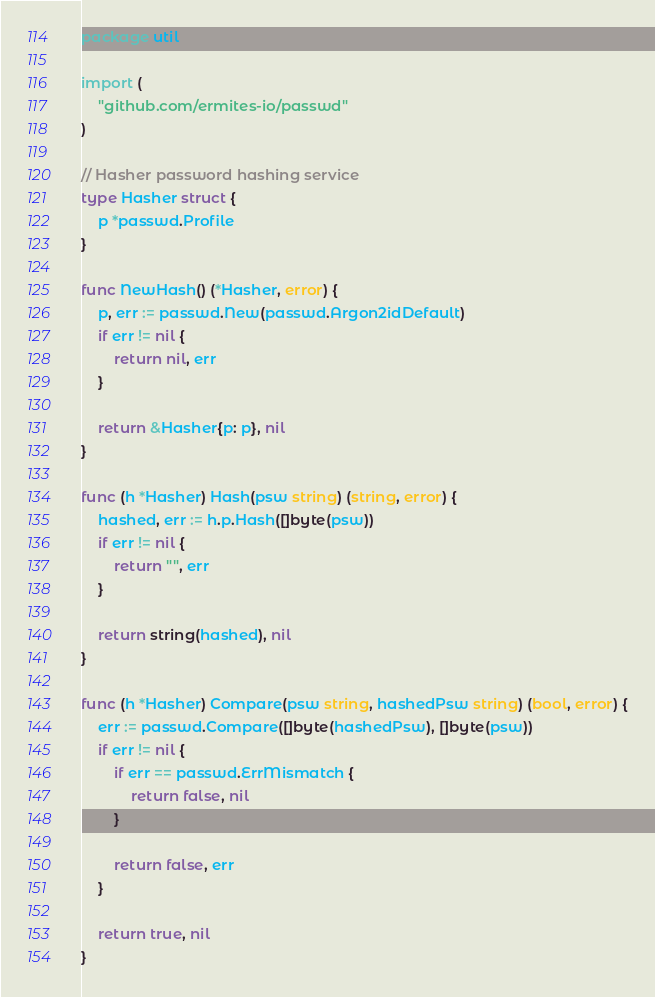Convert code to text. <code><loc_0><loc_0><loc_500><loc_500><_Go_>package util

import (
	"github.com/ermites-io/passwd"
)

// Hasher password hashing service
type Hasher struct {
	p *passwd.Profile
}

func NewHash() (*Hasher, error) {
	p, err := passwd.New(passwd.Argon2idDefault)
	if err != nil {
		return nil, err
	}

	return &Hasher{p: p}, nil
}

func (h *Hasher) Hash(psw string) (string, error) {
	hashed, err := h.p.Hash([]byte(psw))
	if err != nil {
		return "", err
	}

	return string(hashed), nil
}

func (h *Hasher) Compare(psw string, hashedPsw string) (bool, error) {
	err := passwd.Compare([]byte(hashedPsw), []byte(psw))
	if err != nil {
		if err == passwd.ErrMismatch {
			return false, nil
		}

		return false, err
	}

	return true, nil
}
</code> 